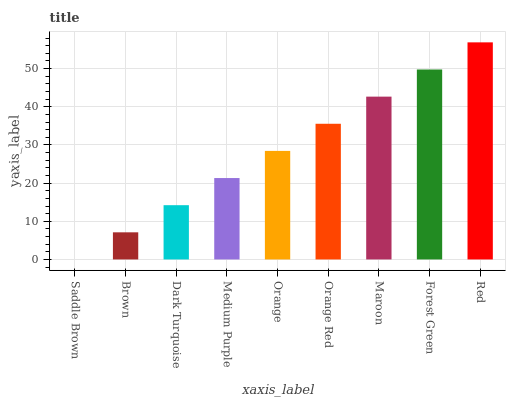Is Saddle Brown the minimum?
Answer yes or no. Yes. Is Red the maximum?
Answer yes or no. Yes. Is Brown the minimum?
Answer yes or no. No. Is Brown the maximum?
Answer yes or no. No. Is Brown greater than Saddle Brown?
Answer yes or no. Yes. Is Saddle Brown less than Brown?
Answer yes or no. Yes. Is Saddle Brown greater than Brown?
Answer yes or no. No. Is Brown less than Saddle Brown?
Answer yes or no. No. Is Orange the high median?
Answer yes or no. Yes. Is Orange the low median?
Answer yes or no. Yes. Is Maroon the high median?
Answer yes or no. No. Is Medium Purple the low median?
Answer yes or no. No. 